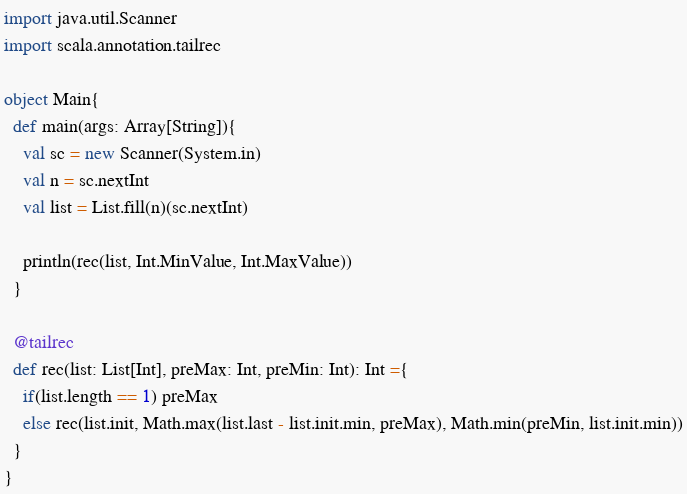<code> <loc_0><loc_0><loc_500><loc_500><_Scala_>import java.util.Scanner
import scala.annotation.tailrec

object Main{
  def main(args: Array[String]){
    val sc = new Scanner(System.in)
    val n = sc.nextInt
    val list = List.fill(n)(sc.nextInt)

    println(rec(list, Int.MinValue, Int.MaxValue))
  }

  @tailrec
  def rec(list: List[Int], preMax: Int, preMin: Int): Int ={
    if(list.length == 1) preMax
    else rec(list.init, Math.max(list.last - list.init.min, preMax), Math.min(preMin, list.init.min))
  }
}</code> 